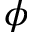Convert formula to latex. <formula><loc_0><loc_0><loc_500><loc_500>\phi</formula> 